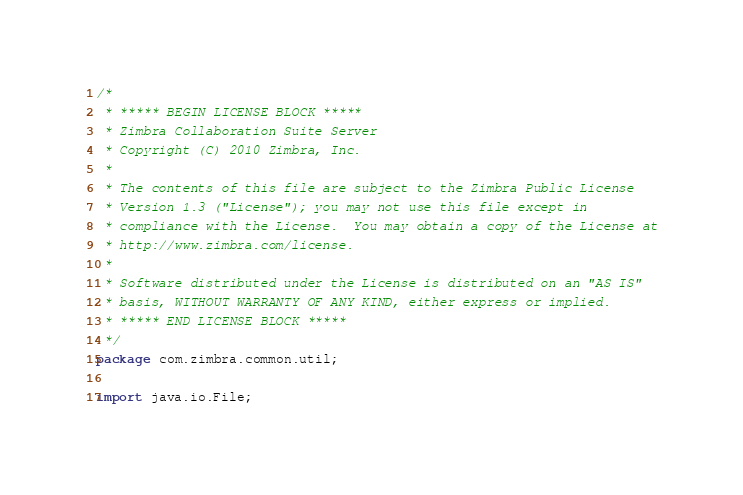Convert code to text. <code><loc_0><loc_0><loc_500><loc_500><_Java_>/*
 * ***** BEGIN LICENSE BLOCK *****
 * Zimbra Collaboration Suite Server
 * Copyright (C) 2010 Zimbra, Inc.
 * 
 * The contents of this file are subject to the Zimbra Public License
 * Version 1.3 ("License"); you may not use this file except in
 * compliance with the License.  You may obtain a copy of the License at
 * http://www.zimbra.com/license.
 * 
 * Software distributed under the License is distributed on an "AS IS"
 * basis, WITHOUT WARRANTY OF ANY KIND, either express or implied.
 * ***** END LICENSE BLOCK *****
 */
package com.zimbra.common.util;

import java.io.File;</code> 